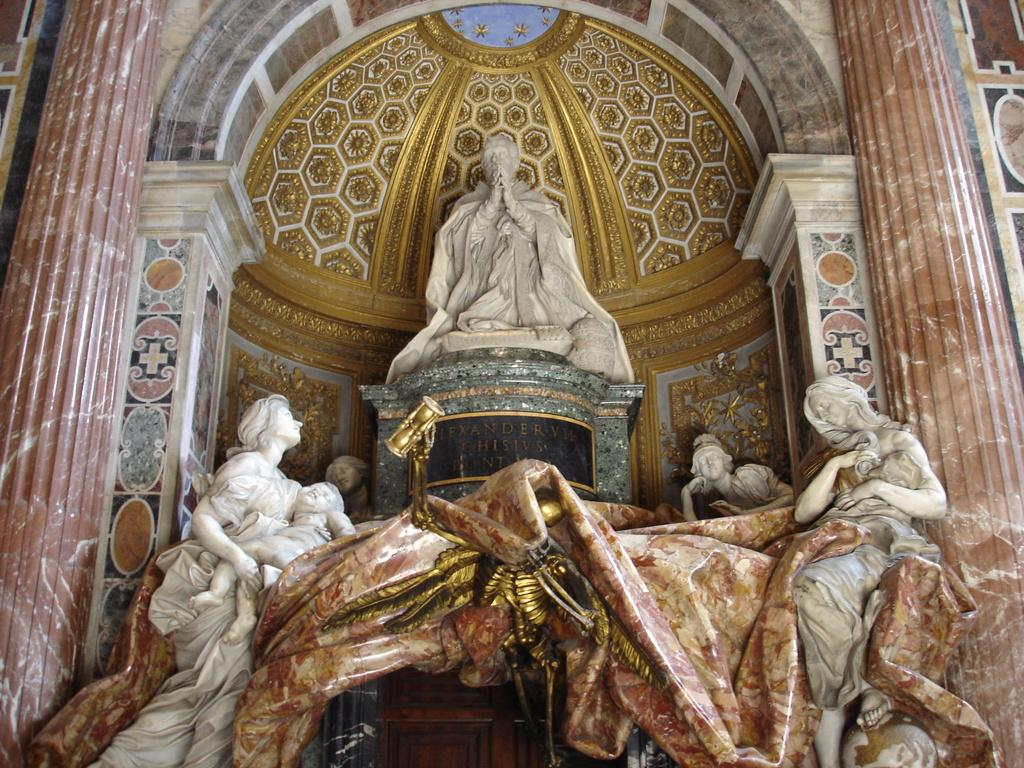What type of structures can be seen in the image? There are statues in the image. What can be seen in the background of the image? There is a designed wall in the image. What else is present in the image besides the statues and wall? There are objects in the image. What caption is written below the statues in the image? There is no caption visible in the image; it only contains statues and a designed wall. 